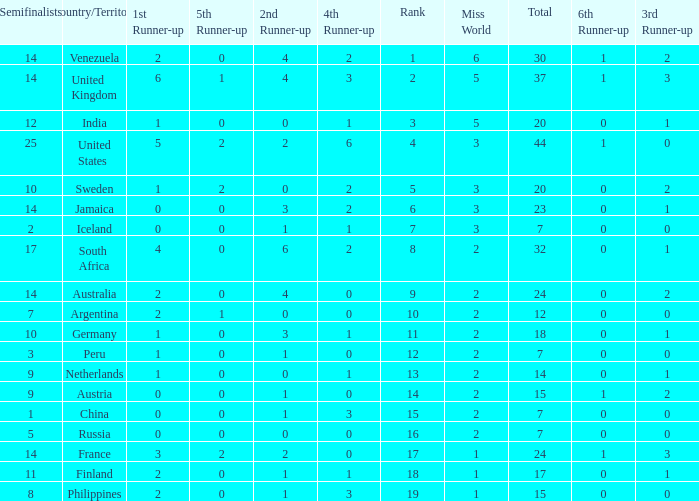Which countries have a 5th runner-up ranking is 2 and the 3rd runner-up ranking is 0 44.0. 